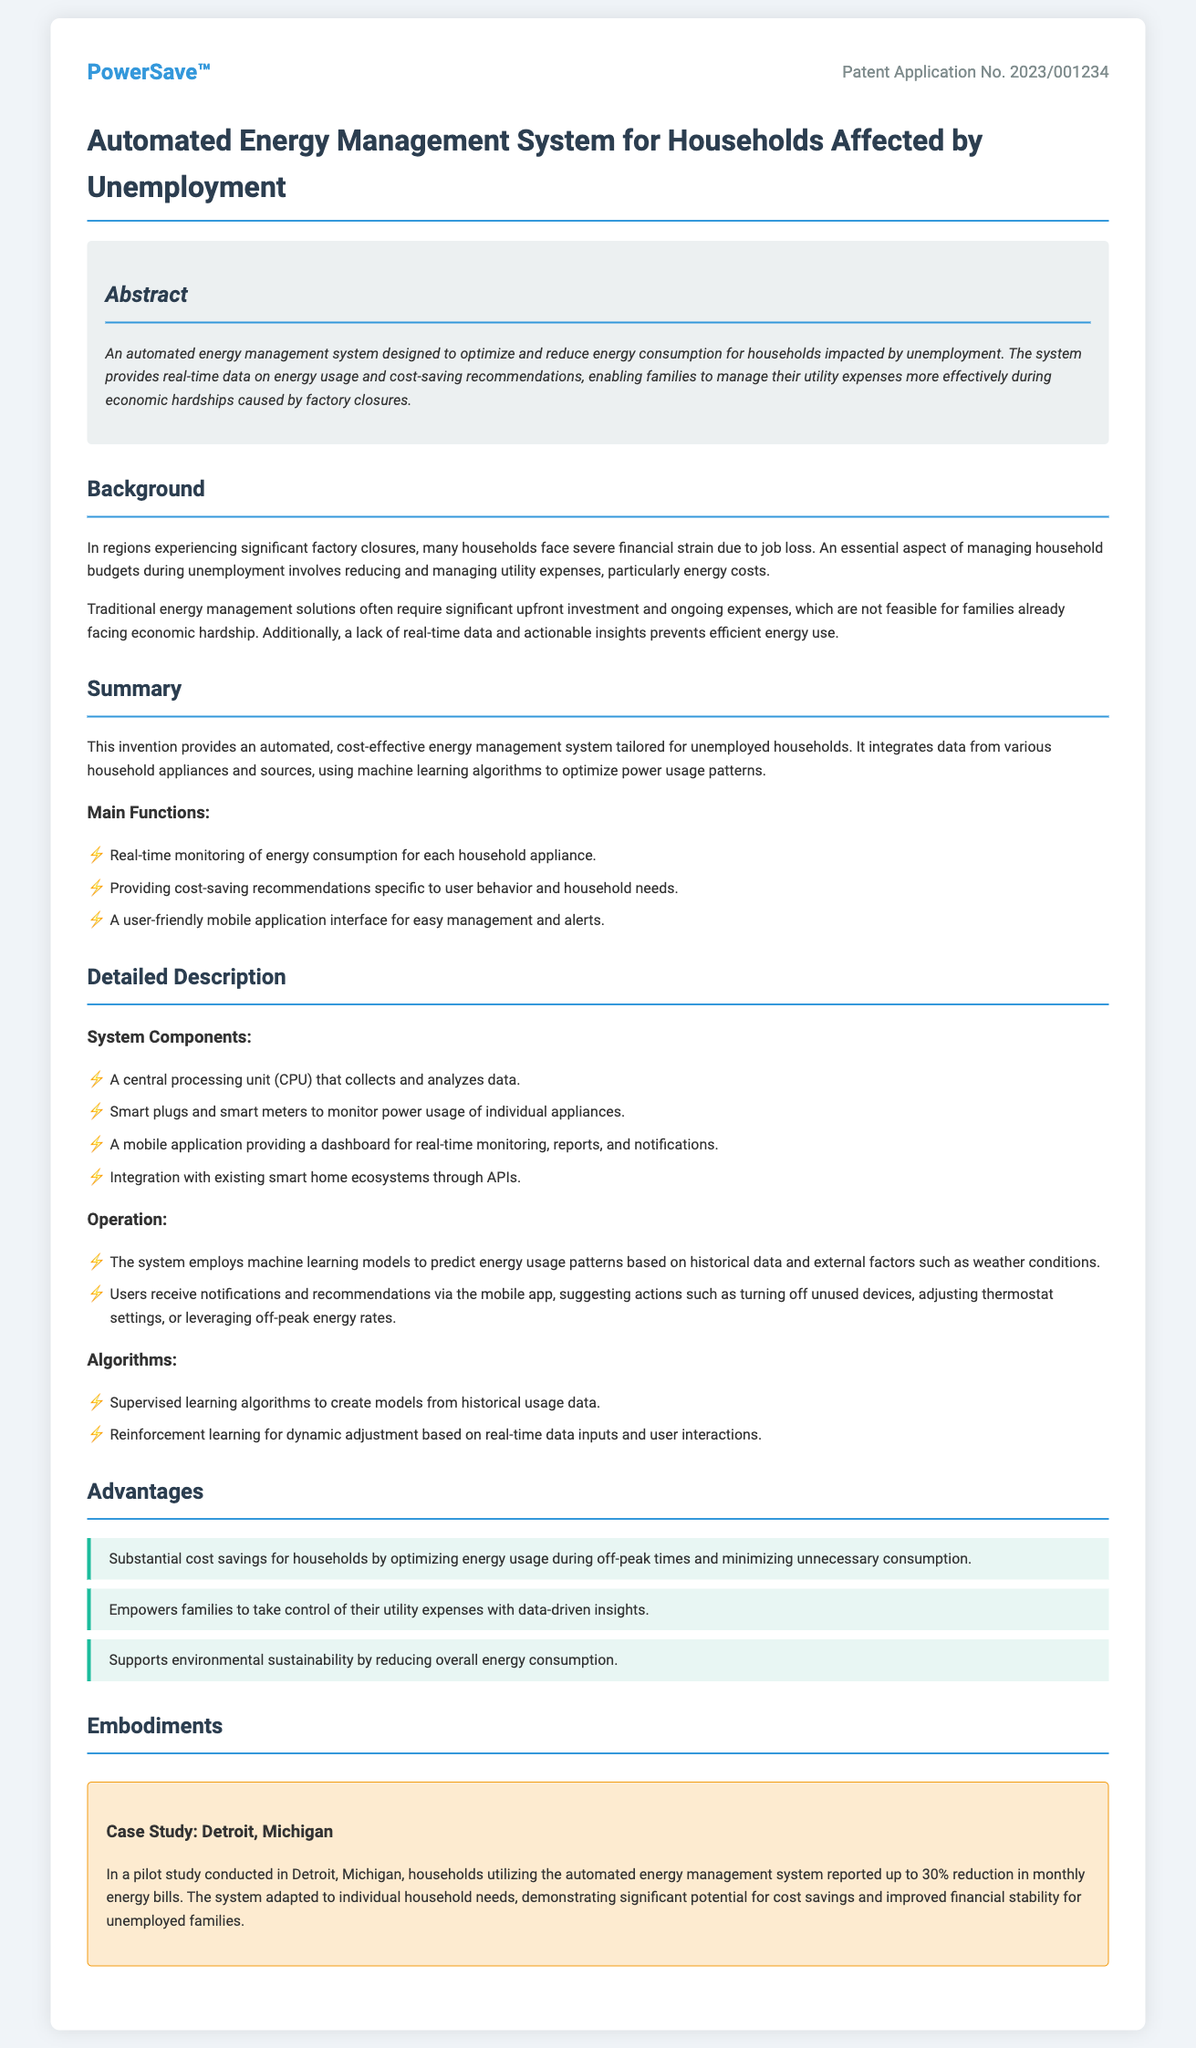What is the patent application number? The patent application number is specified at the top of the document.
Answer: 2023/001234 What is the main purpose of the automated energy management system? The purpose is described in the abstract section regarding energy consumption optimization.
Answer: Optimize and reduce energy consumption What is one main function of the system? Functions are listed in the summary section, and one is provided for easy identification.
Answer: Real-time monitoring of energy consumption Which type of algorithms does the system use for dynamic adjustment? The detailed description mentions the algorithm types used in this system.
Answer: Reinforcement learning What is the percentage reduction in monthly energy bills reported in the Detroit case study? The case study specifies the outcome regarding energy bill reduction.
Answer: 30% What is one advantage of the automated energy management system? The advantages are outlined in the advantages section, highlighting significant benefits.
Answer: Substantial cost savings What does the system integrate with to enhance its functionality? The detailed description outlines the system's integration capabilities with other technologies.
Answer: Existing smart home ecosystems In what economic situation is this energy management system particularly beneficial? The background section explains the specific economic context for the system's use.
Answer: Unemployment 